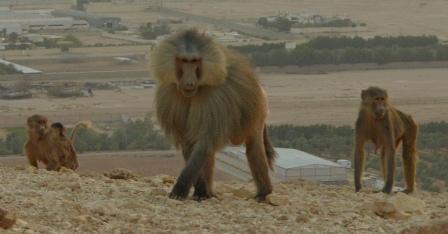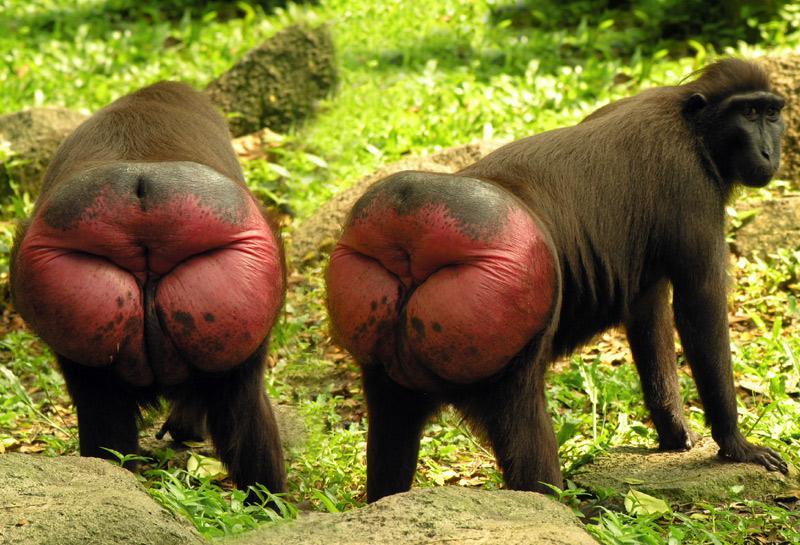The first image is the image on the left, the second image is the image on the right. Assess this claim about the two images: "An image containing no more than 3 apes includes a young baboon riding on an adult baboon.". Correct or not? Answer yes or no. No. The first image is the image on the left, the second image is the image on the right. Examine the images to the left and right. Is the description "At least one of the images contains a baby monkey." accurate? Answer yes or no. No. 